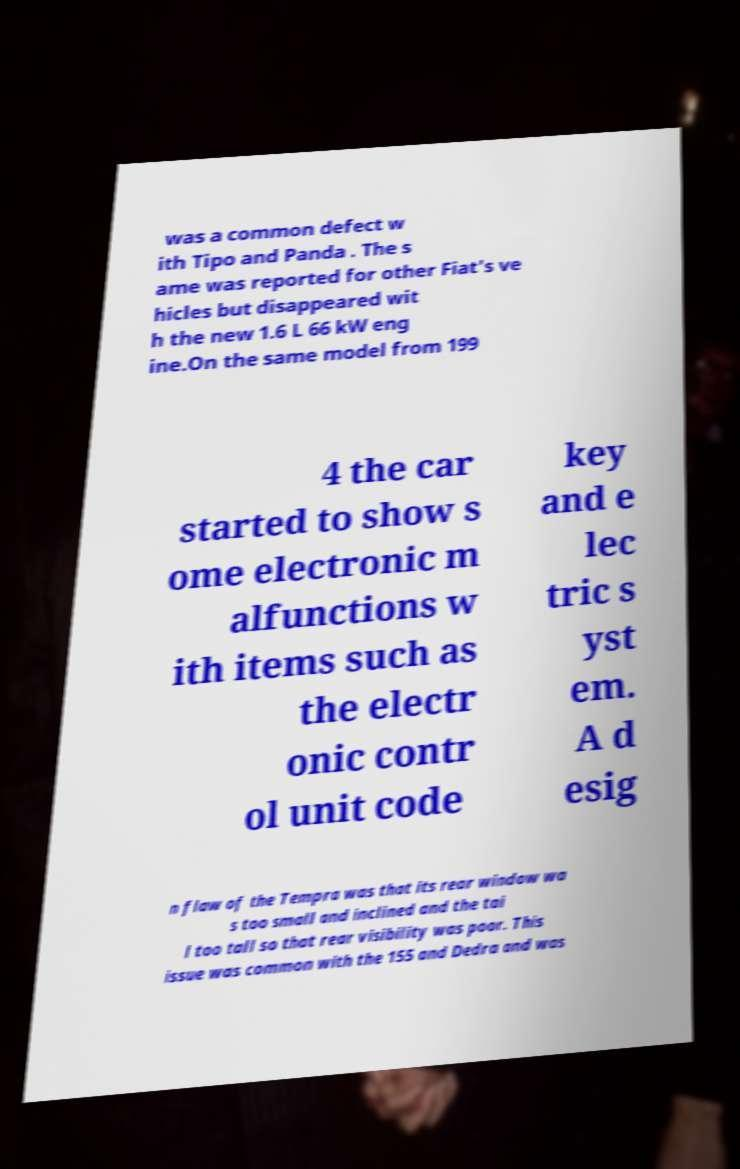There's text embedded in this image that I need extracted. Can you transcribe it verbatim? was a common defect w ith Tipo and Panda . The s ame was reported for other Fiat's ve hicles but disappeared wit h the new 1.6 L 66 kW eng ine.On the same model from 199 4 the car started to show s ome electronic m alfunctions w ith items such as the electr onic contr ol unit code key and e lec tric s yst em. A d esig n flaw of the Tempra was that its rear window wa s too small and inclined and the tai l too tall so that rear visibility was poor. This issue was common with the 155 and Dedra and was 